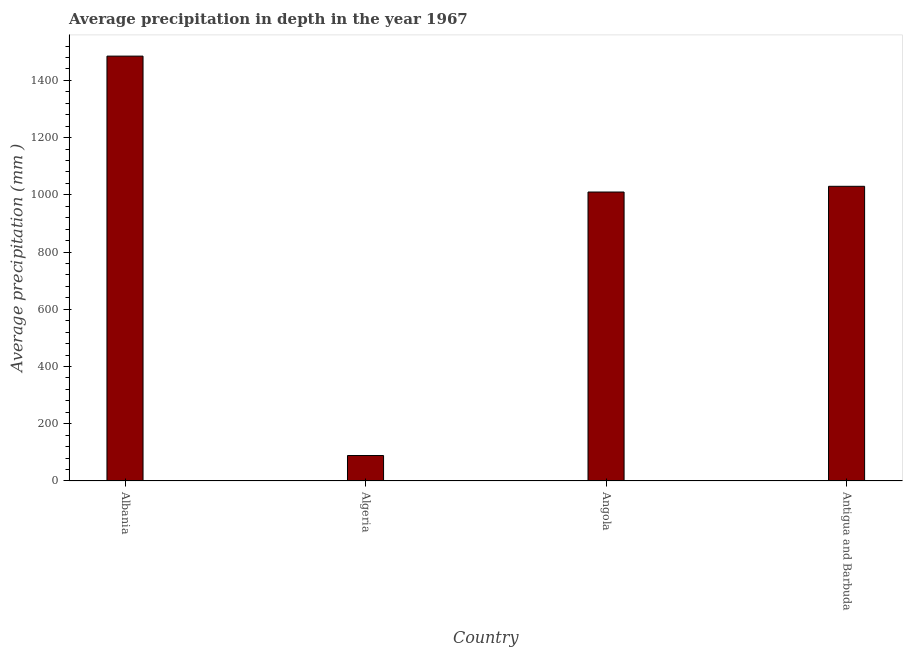Does the graph contain any zero values?
Offer a terse response. No. What is the title of the graph?
Provide a succinct answer. Average precipitation in depth in the year 1967. What is the label or title of the Y-axis?
Offer a terse response. Average precipitation (mm ). What is the average precipitation in depth in Algeria?
Your response must be concise. 89. Across all countries, what is the maximum average precipitation in depth?
Your answer should be compact. 1485. Across all countries, what is the minimum average precipitation in depth?
Provide a succinct answer. 89. In which country was the average precipitation in depth maximum?
Make the answer very short. Albania. In which country was the average precipitation in depth minimum?
Make the answer very short. Algeria. What is the sum of the average precipitation in depth?
Keep it short and to the point. 3614. What is the difference between the average precipitation in depth in Albania and Antigua and Barbuda?
Provide a succinct answer. 455. What is the average average precipitation in depth per country?
Offer a very short reply. 903. What is the median average precipitation in depth?
Your response must be concise. 1020. In how many countries, is the average precipitation in depth greater than 360 mm?
Offer a terse response. 3. What is the ratio of the average precipitation in depth in Albania to that in Angola?
Keep it short and to the point. 1.47. What is the difference between the highest and the second highest average precipitation in depth?
Your answer should be very brief. 455. Is the sum of the average precipitation in depth in Algeria and Antigua and Barbuda greater than the maximum average precipitation in depth across all countries?
Provide a short and direct response. No. What is the difference between the highest and the lowest average precipitation in depth?
Offer a very short reply. 1396. Are all the bars in the graph horizontal?
Offer a very short reply. No. How many countries are there in the graph?
Provide a short and direct response. 4. What is the difference between two consecutive major ticks on the Y-axis?
Your answer should be very brief. 200. What is the Average precipitation (mm ) of Albania?
Provide a succinct answer. 1485. What is the Average precipitation (mm ) of Algeria?
Keep it short and to the point. 89. What is the Average precipitation (mm ) of Angola?
Offer a very short reply. 1010. What is the Average precipitation (mm ) of Antigua and Barbuda?
Offer a terse response. 1030. What is the difference between the Average precipitation (mm ) in Albania and Algeria?
Provide a short and direct response. 1396. What is the difference between the Average precipitation (mm ) in Albania and Angola?
Keep it short and to the point. 475. What is the difference between the Average precipitation (mm ) in Albania and Antigua and Barbuda?
Ensure brevity in your answer.  455. What is the difference between the Average precipitation (mm ) in Algeria and Angola?
Make the answer very short. -921. What is the difference between the Average precipitation (mm ) in Algeria and Antigua and Barbuda?
Your answer should be very brief. -941. What is the ratio of the Average precipitation (mm ) in Albania to that in Algeria?
Offer a very short reply. 16.68. What is the ratio of the Average precipitation (mm ) in Albania to that in Angola?
Provide a succinct answer. 1.47. What is the ratio of the Average precipitation (mm ) in Albania to that in Antigua and Barbuda?
Your response must be concise. 1.44. What is the ratio of the Average precipitation (mm ) in Algeria to that in Angola?
Offer a terse response. 0.09. What is the ratio of the Average precipitation (mm ) in Algeria to that in Antigua and Barbuda?
Give a very brief answer. 0.09. What is the ratio of the Average precipitation (mm ) in Angola to that in Antigua and Barbuda?
Give a very brief answer. 0.98. 